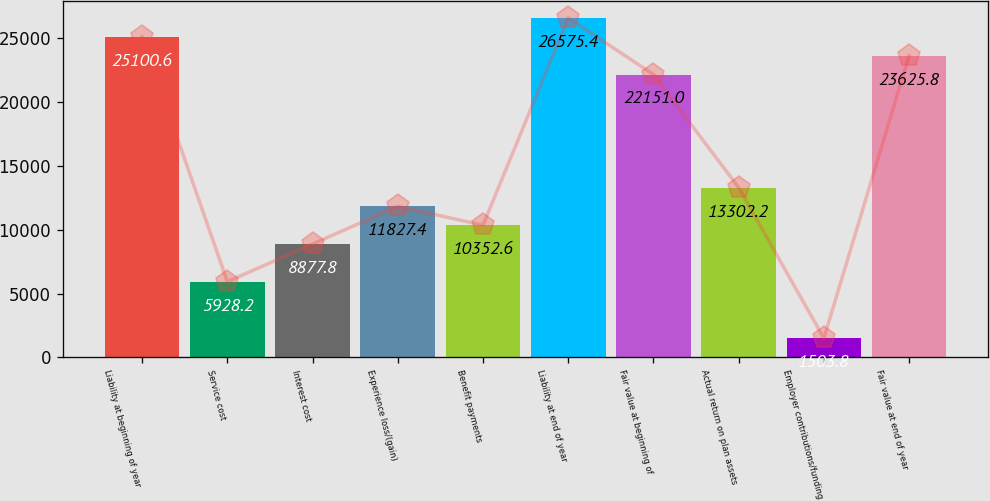Convert chart. <chart><loc_0><loc_0><loc_500><loc_500><bar_chart><fcel>Liability at beginning of year<fcel>Service cost<fcel>Interest cost<fcel>Experience loss/(gain)<fcel>Benefit payments<fcel>Liability at end of year<fcel>Fair value at beginning of<fcel>Actual return on plan assets<fcel>Employer contributions/funding<fcel>Fair value at end of year<nl><fcel>25100.6<fcel>5928.2<fcel>8877.8<fcel>11827.4<fcel>10352.6<fcel>26575.4<fcel>22151<fcel>13302.2<fcel>1503.8<fcel>23625.8<nl></chart> 